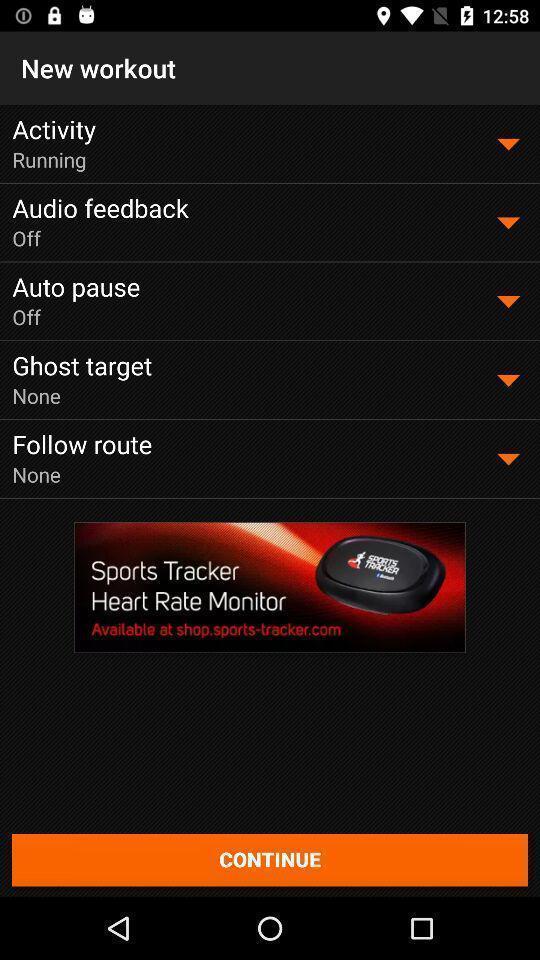What details can you identify in this image? Page displaying various options in fitness app. 